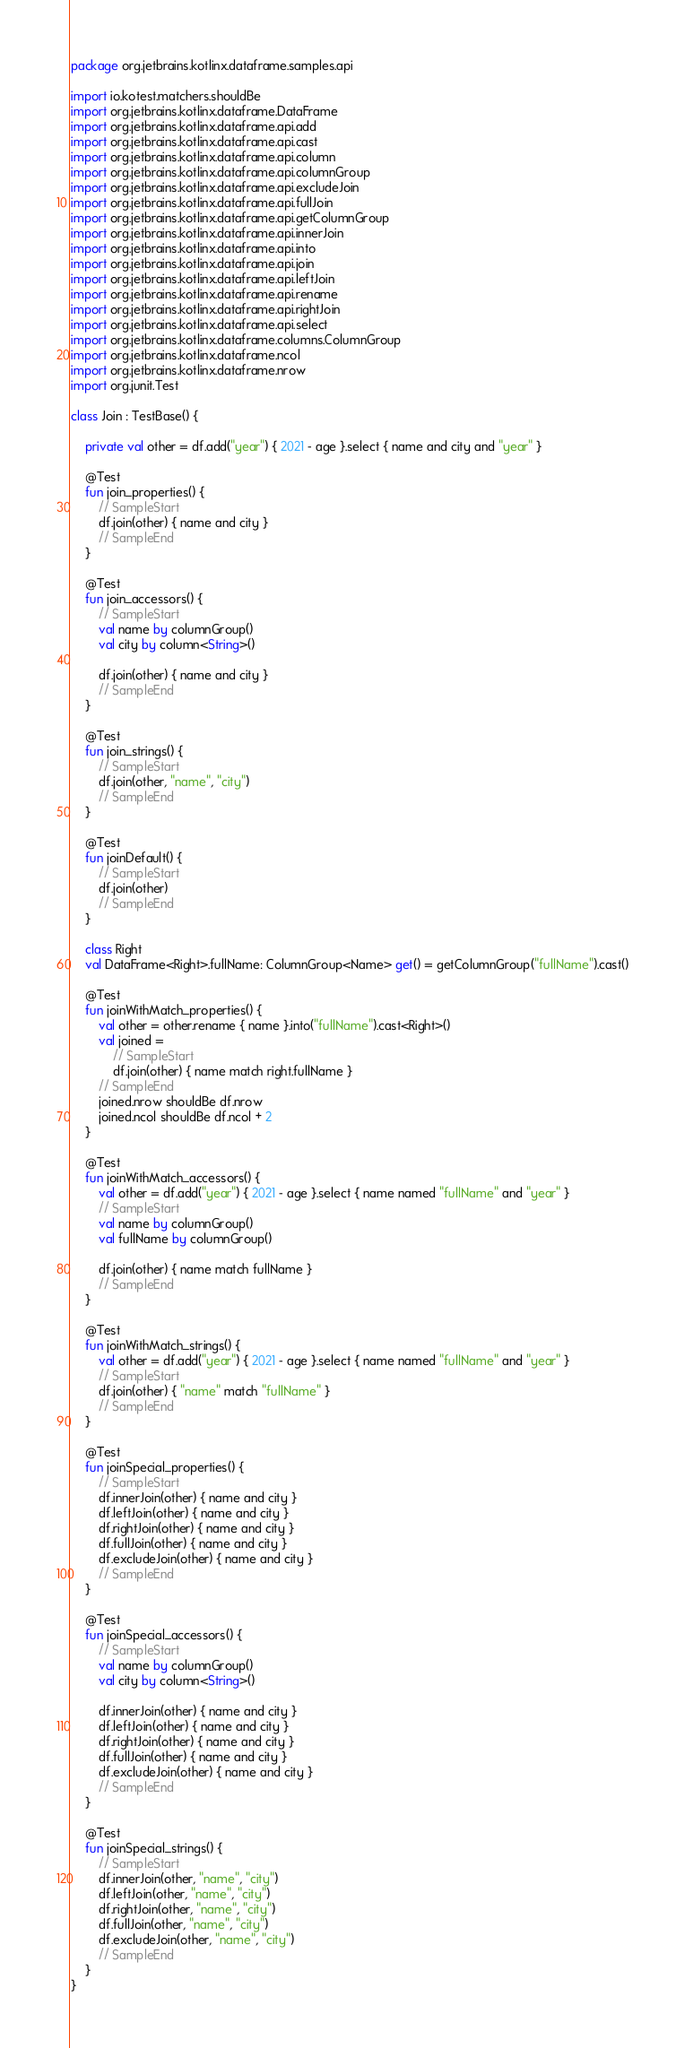<code> <loc_0><loc_0><loc_500><loc_500><_Kotlin_>package org.jetbrains.kotlinx.dataframe.samples.api

import io.kotest.matchers.shouldBe
import org.jetbrains.kotlinx.dataframe.DataFrame
import org.jetbrains.kotlinx.dataframe.api.add
import org.jetbrains.kotlinx.dataframe.api.cast
import org.jetbrains.kotlinx.dataframe.api.column
import org.jetbrains.kotlinx.dataframe.api.columnGroup
import org.jetbrains.kotlinx.dataframe.api.excludeJoin
import org.jetbrains.kotlinx.dataframe.api.fullJoin
import org.jetbrains.kotlinx.dataframe.api.getColumnGroup
import org.jetbrains.kotlinx.dataframe.api.innerJoin
import org.jetbrains.kotlinx.dataframe.api.into
import org.jetbrains.kotlinx.dataframe.api.join
import org.jetbrains.kotlinx.dataframe.api.leftJoin
import org.jetbrains.kotlinx.dataframe.api.rename
import org.jetbrains.kotlinx.dataframe.api.rightJoin
import org.jetbrains.kotlinx.dataframe.api.select
import org.jetbrains.kotlinx.dataframe.columns.ColumnGroup
import org.jetbrains.kotlinx.dataframe.ncol
import org.jetbrains.kotlinx.dataframe.nrow
import org.junit.Test

class Join : TestBase() {

    private val other = df.add("year") { 2021 - age }.select { name and city and "year" }

    @Test
    fun join_properties() {
        // SampleStart
        df.join(other) { name and city }
        // SampleEnd
    }

    @Test
    fun join_accessors() {
        // SampleStart
        val name by columnGroup()
        val city by column<String>()

        df.join(other) { name and city }
        // SampleEnd
    }

    @Test
    fun join_strings() {
        // SampleStart
        df.join(other, "name", "city")
        // SampleEnd
    }

    @Test
    fun joinDefault() {
        // SampleStart
        df.join(other)
        // SampleEnd
    }

    class Right
    val DataFrame<Right>.fullName: ColumnGroup<Name> get() = getColumnGroup("fullName").cast()

    @Test
    fun joinWithMatch_properties() {
        val other = other.rename { name }.into("fullName").cast<Right>()
        val joined =
            // SampleStart
            df.join(other) { name match right.fullName }
        // SampleEnd
        joined.nrow shouldBe df.nrow
        joined.ncol shouldBe df.ncol + 2
    }

    @Test
    fun joinWithMatch_accessors() {
        val other = df.add("year") { 2021 - age }.select { name named "fullName" and "year" }
        // SampleStart
        val name by columnGroup()
        val fullName by columnGroup()

        df.join(other) { name match fullName }
        // SampleEnd
    }

    @Test
    fun joinWithMatch_strings() {
        val other = df.add("year") { 2021 - age }.select { name named "fullName" and "year" }
        // SampleStart
        df.join(other) { "name" match "fullName" }
        // SampleEnd
    }

    @Test
    fun joinSpecial_properties() {
        // SampleStart
        df.innerJoin(other) { name and city }
        df.leftJoin(other) { name and city }
        df.rightJoin(other) { name and city }
        df.fullJoin(other) { name and city }
        df.excludeJoin(other) { name and city }
        // SampleEnd
    }

    @Test
    fun joinSpecial_accessors() {
        // SampleStart
        val name by columnGroup()
        val city by column<String>()

        df.innerJoin(other) { name and city }
        df.leftJoin(other) { name and city }
        df.rightJoin(other) { name and city }
        df.fullJoin(other) { name and city }
        df.excludeJoin(other) { name and city }
        // SampleEnd
    }

    @Test
    fun joinSpecial_strings() {
        // SampleStart
        df.innerJoin(other, "name", "city")
        df.leftJoin(other, "name", "city")
        df.rightJoin(other, "name", "city")
        df.fullJoin(other, "name", "city")
        df.excludeJoin(other, "name", "city")
        // SampleEnd
    }
}
</code> 